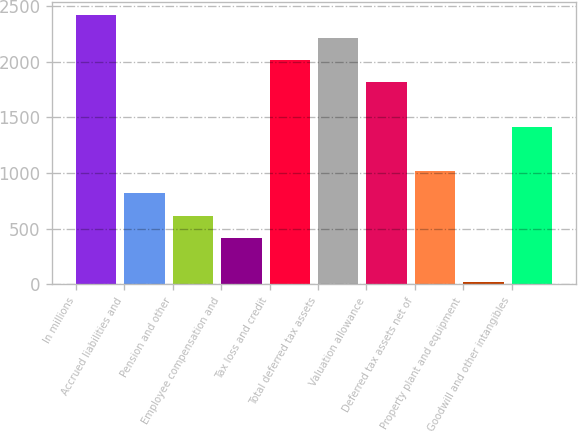Convert chart to OTSL. <chart><loc_0><loc_0><loc_500><loc_500><bar_chart><fcel>In millions<fcel>Accrued liabilities and<fcel>Pension and other<fcel>Employee compensation and<fcel>Tax loss and credit<fcel>Total deferred tax assets<fcel>Valuation allowance<fcel>Deferred tax assets net of<fcel>Property plant and equipment<fcel>Goodwill and other intangibles<nl><fcel>2417.1<fcel>816.7<fcel>616.65<fcel>416.6<fcel>2017<fcel>2217.05<fcel>1816.95<fcel>1016.75<fcel>16.5<fcel>1416.85<nl></chart> 